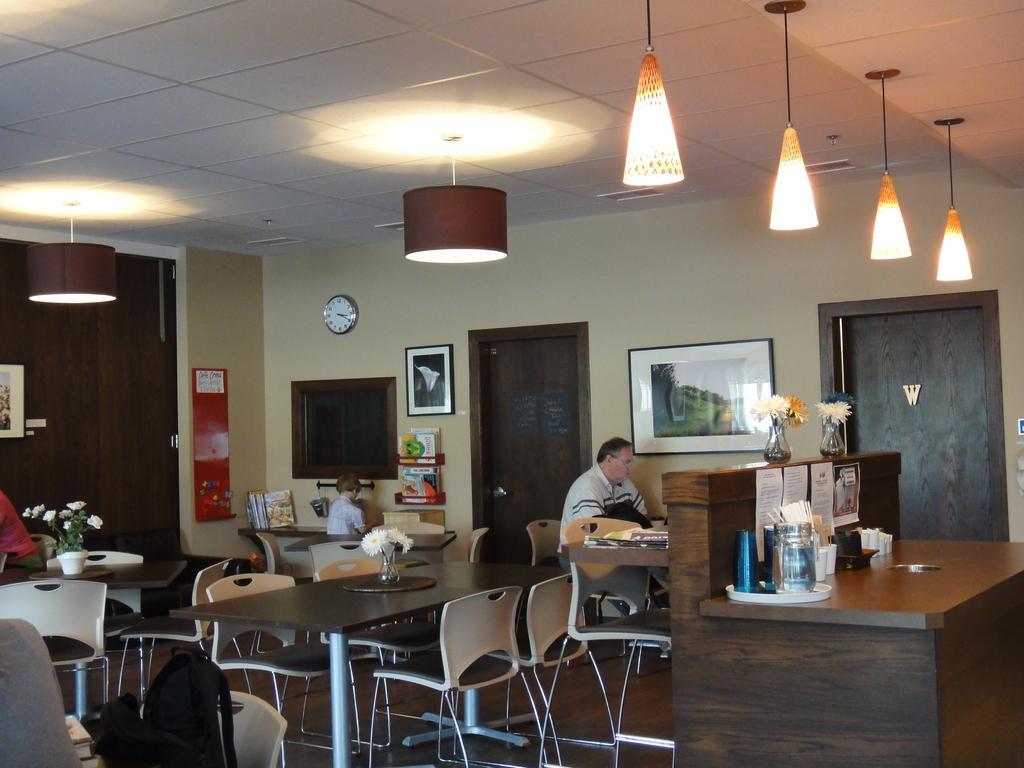Can you describe this image briefly? In this picture we can see man sitting on chair, table and on table we have flower vase , here is the boy and in background we can see wall, frames, lights, doors, papers. 